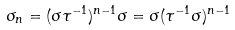<formula> <loc_0><loc_0><loc_500><loc_500>\sigma _ { n } = ( \sigma \tau ^ { - 1 } ) ^ { n - 1 } \sigma = \sigma ( \tau ^ { - 1 } \sigma ) ^ { n - 1 }</formula> 